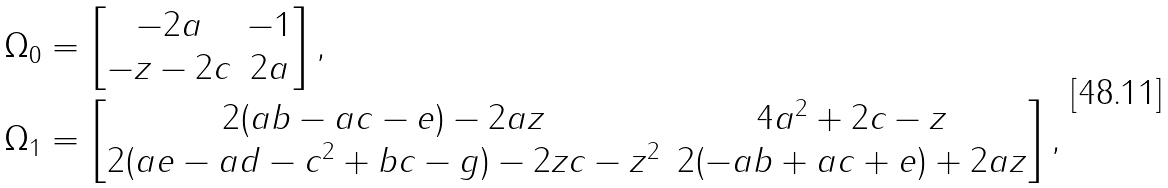Convert formula to latex. <formula><loc_0><loc_0><loc_500><loc_500>\Omega _ { 0 } & = \begin{bmatrix} - 2 a & - 1 \\ - z - 2 c & 2 a \end{bmatrix} , \\ \Omega _ { 1 } & = \begin{bmatrix} 2 ( a b - a c - e ) - 2 a z & 4 a ^ { 2 } + 2 c - z \\ 2 ( a e - a d - c ^ { 2 } + b c - g ) - 2 z c - z ^ { 2 } & 2 ( - a b + a c + e ) + 2 a z \end{bmatrix} ,</formula> 